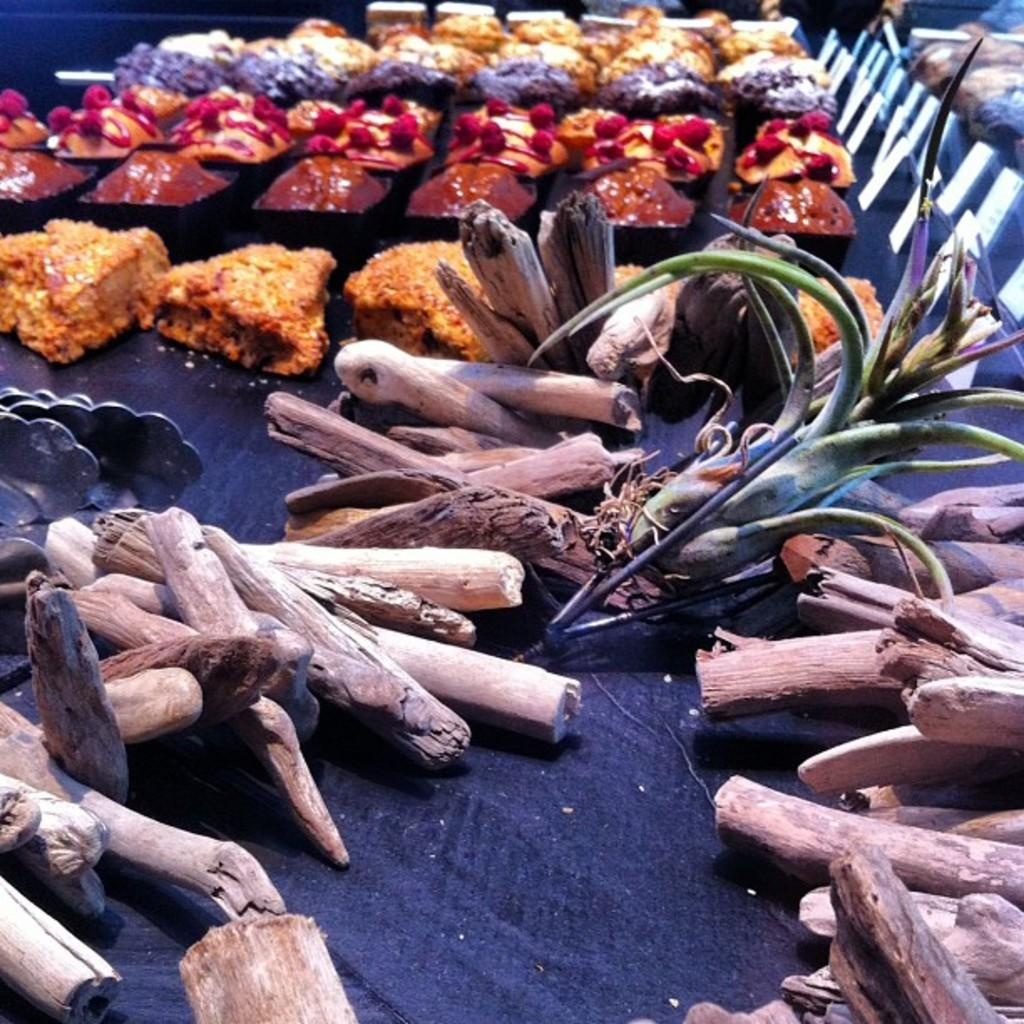What types of items can be seen in the image? There are food items and wood placed on a table in the image. Can you describe the food items in the image? Unfortunately, the specific food items cannot be identified from the provided facts. What is the wood placed on in the image? The wood is placed on a table in the image. What type of corn is growing in the image? There is no corn present in the image. What guide is being used to navigate the territory in the image? There is no guide or territory present in the image. 